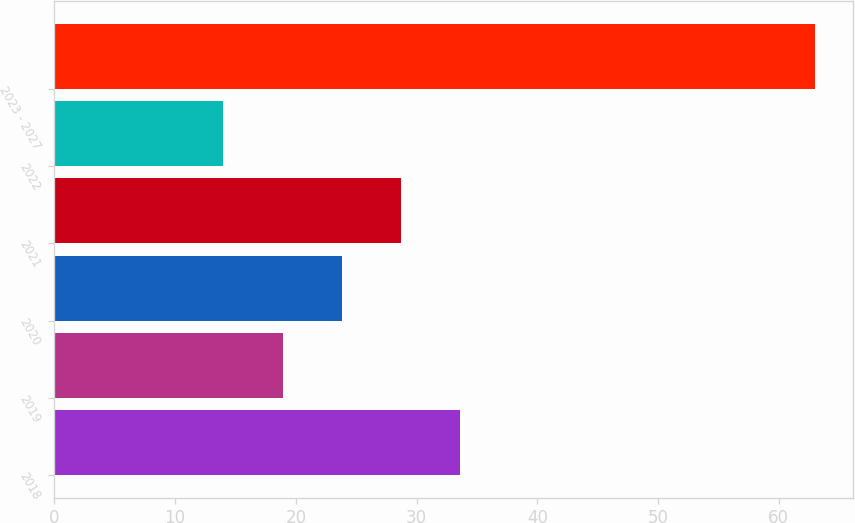Convert chart. <chart><loc_0><loc_0><loc_500><loc_500><bar_chart><fcel>2018<fcel>2019<fcel>2020<fcel>2021<fcel>2022<fcel>2023 - 2027<nl><fcel>33.6<fcel>18.9<fcel>23.8<fcel>28.7<fcel>14<fcel>63<nl></chart> 